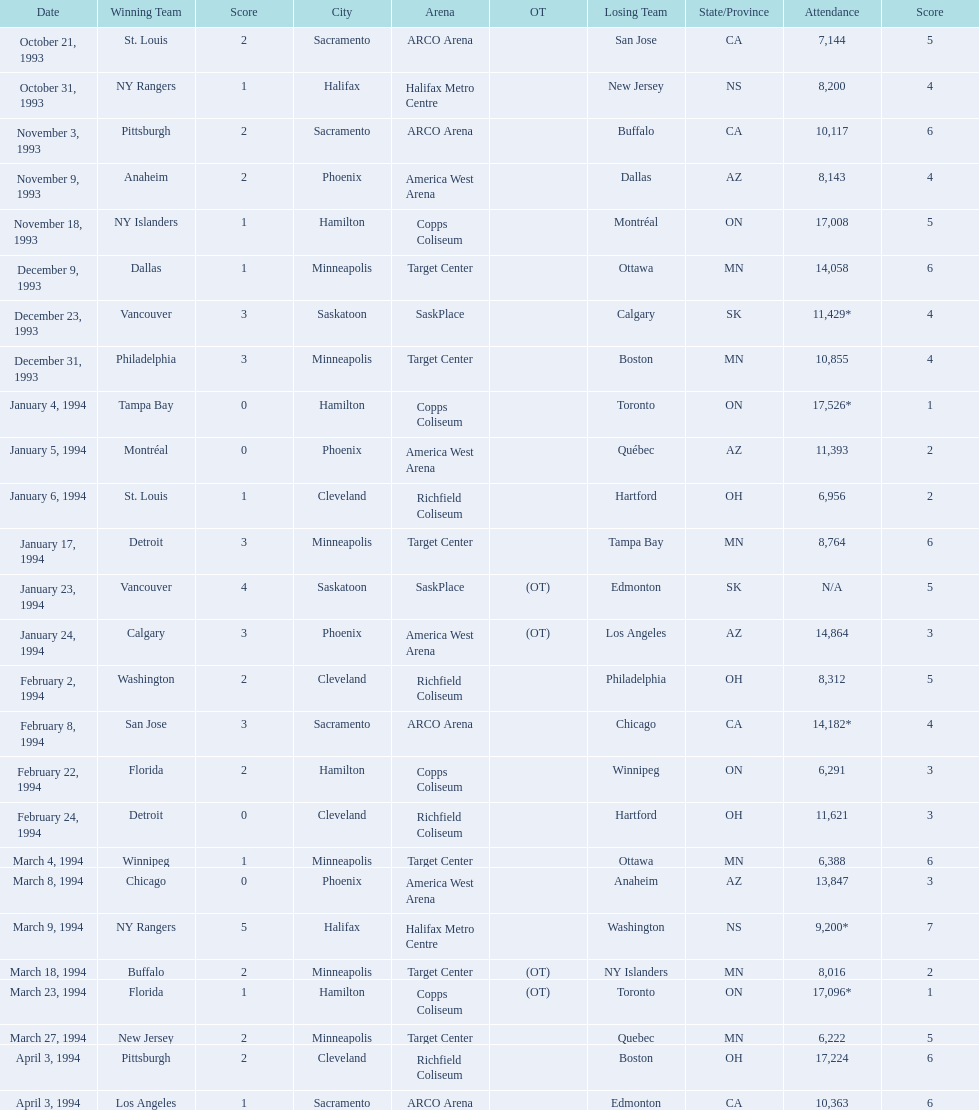What was the attendance on january 24, 1994? 14,864. What was the attendance on december 23, 1993? 11,429*. Between january 24, 1994 and december 23, 1993, which had the higher attendance? January 4, 1994. 